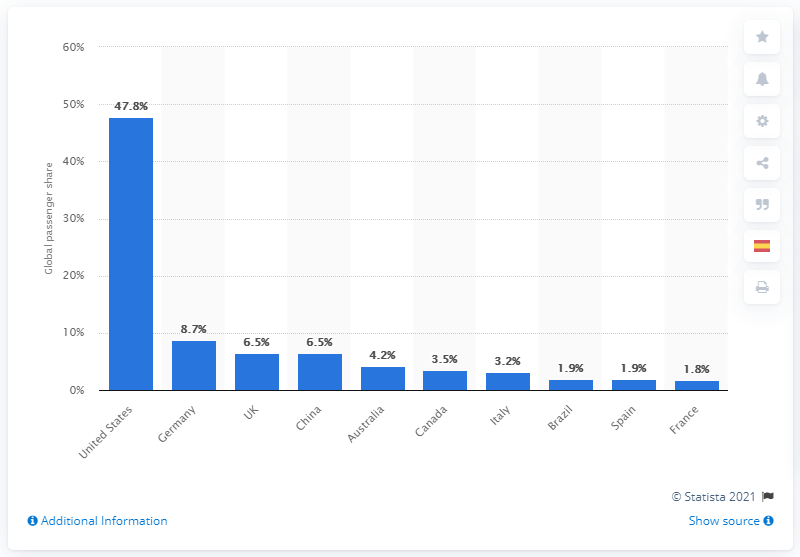Highlight a few significant elements in this photo. In 2019, Germany was the second largest market for cruise passengers. 